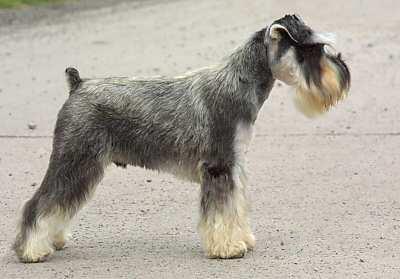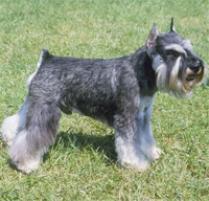The first image is the image on the left, the second image is the image on the right. Analyze the images presented: Is the assertion "The left image shows a schnauzer sitting upright." valid? Answer yes or no. No. The first image is the image on the left, the second image is the image on the right. Considering the images on both sides, is "At least one of the dogs is directly on the grass." valid? Answer yes or no. Yes. 